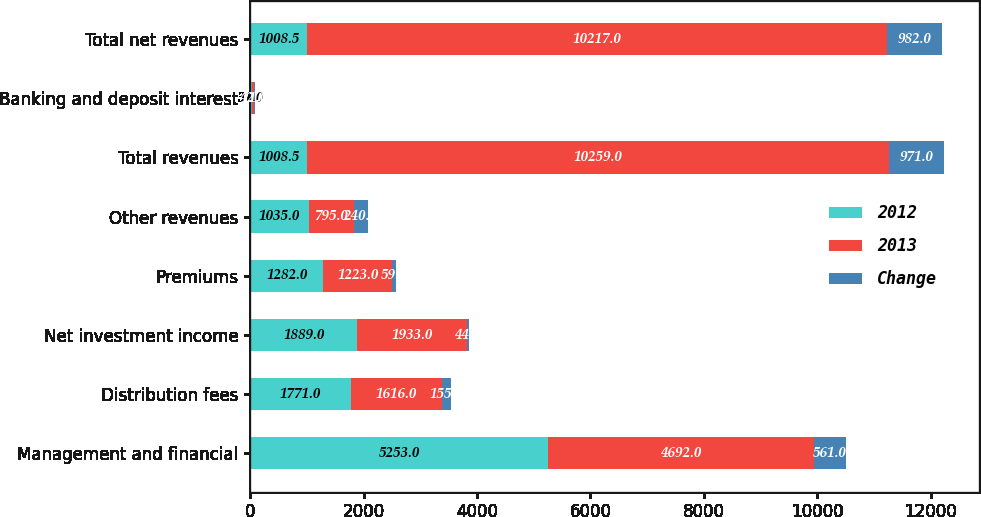Convert chart. <chart><loc_0><loc_0><loc_500><loc_500><stacked_bar_chart><ecel><fcel>Management and financial<fcel>Distribution fees<fcel>Net investment income<fcel>Premiums<fcel>Other revenues<fcel>Total revenues<fcel>Banking and deposit interest<fcel>Total net revenues<nl><fcel>2012<fcel>5253<fcel>1771<fcel>1889<fcel>1282<fcel>1035<fcel>1008.5<fcel>31<fcel>1008.5<nl><fcel>2013<fcel>4692<fcel>1616<fcel>1933<fcel>1223<fcel>795<fcel>10259<fcel>42<fcel>10217<nl><fcel>Change<fcel>561<fcel>155<fcel>44<fcel>59<fcel>240<fcel>971<fcel>11<fcel>982<nl></chart> 